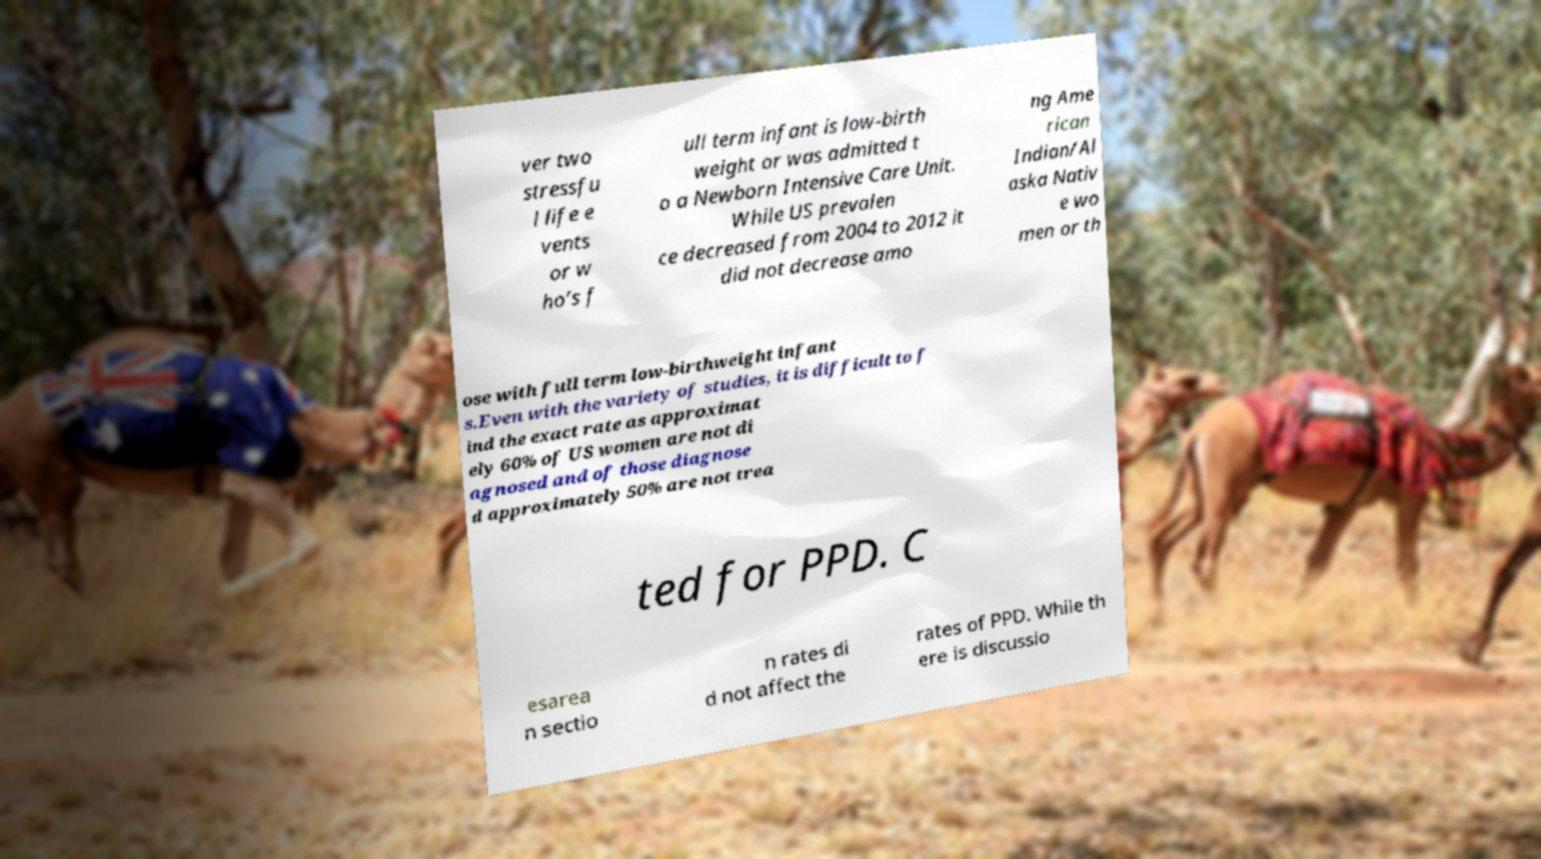Could you assist in decoding the text presented in this image and type it out clearly? ver two stressfu l life e vents or w ho’s f ull term infant is low-birth weight or was admitted t o a Newborn Intensive Care Unit. While US prevalen ce decreased from 2004 to 2012 it did not decrease amo ng Ame rican Indian/Al aska Nativ e wo men or th ose with full term low-birthweight infant s.Even with the variety of studies, it is difficult to f ind the exact rate as approximat ely 60% of US women are not di agnosed and of those diagnose d approximately 50% are not trea ted for PPD. C esarea n sectio n rates di d not affect the rates of PPD. While th ere is discussio 